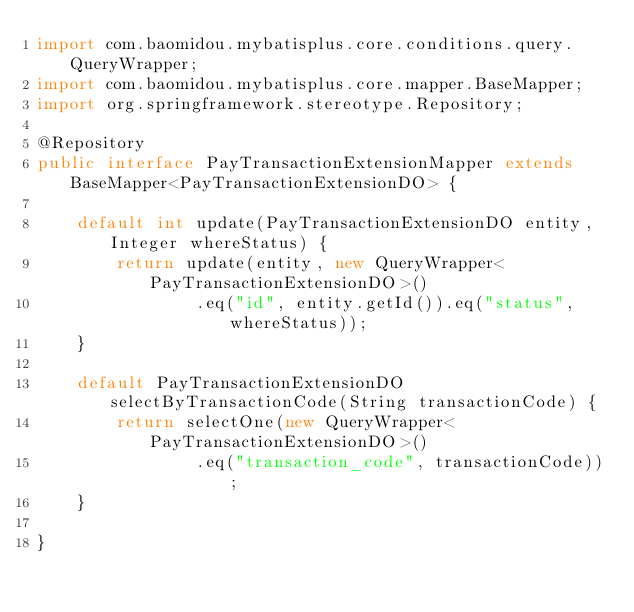Convert code to text. <code><loc_0><loc_0><loc_500><loc_500><_Java_>import com.baomidou.mybatisplus.core.conditions.query.QueryWrapper;
import com.baomidou.mybatisplus.core.mapper.BaseMapper;
import org.springframework.stereotype.Repository;

@Repository
public interface PayTransactionExtensionMapper extends BaseMapper<PayTransactionExtensionDO> {

    default int update(PayTransactionExtensionDO entity, Integer whereStatus) {
        return update(entity, new QueryWrapper<PayTransactionExtensionDO>()
                .eq("id", entity.getId()).eq("status", whereStatus));
    }

    default PayTransactionExtensionDO selectByTransactionCode(String transactionCode) {
        return selectOne(new QueryWrapper<PayTransactionExtensionDO>()
                .eq("transaction_code", transactionCode));
    }

}
</code> 